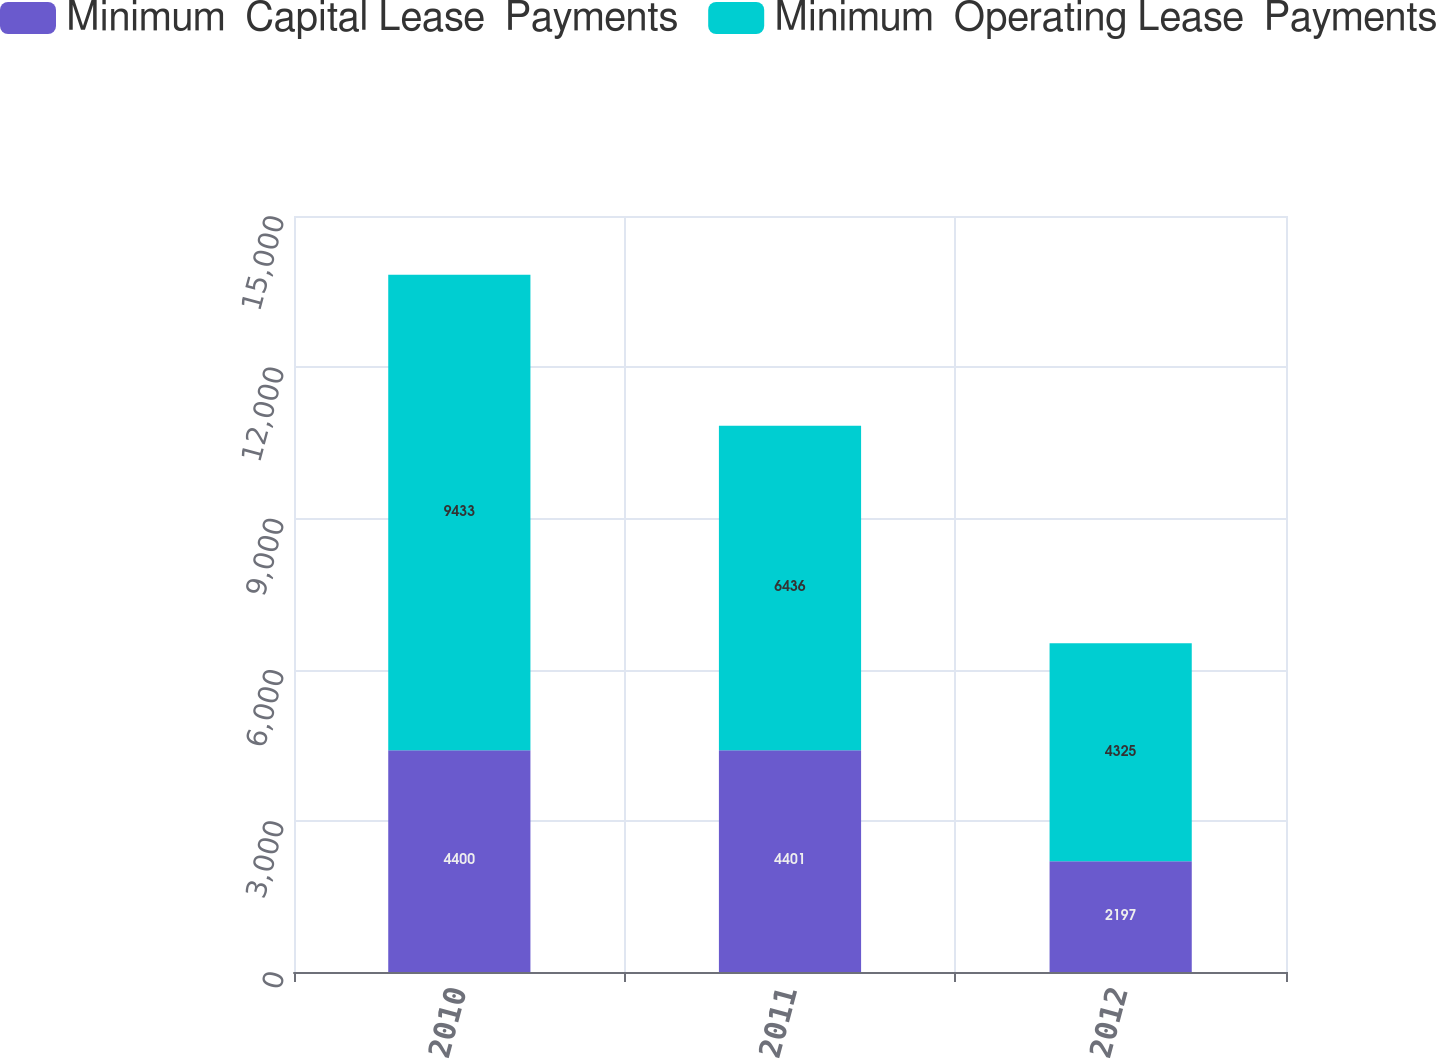<chart> <loc_0><loc_0><loc_500><loc_500><stacked_bar_chart><ecel><fcel>2010<fcel>2011<fcel>2012<nl><fcel>Minimum  Capital Lease  Payments<fcel>4400<fcel>4401<fcel>2197<nl><fcel>Minimum  Operating Lease  Payments<fcel>9433<fcel>6436<fcel>4325<nl></chart> 